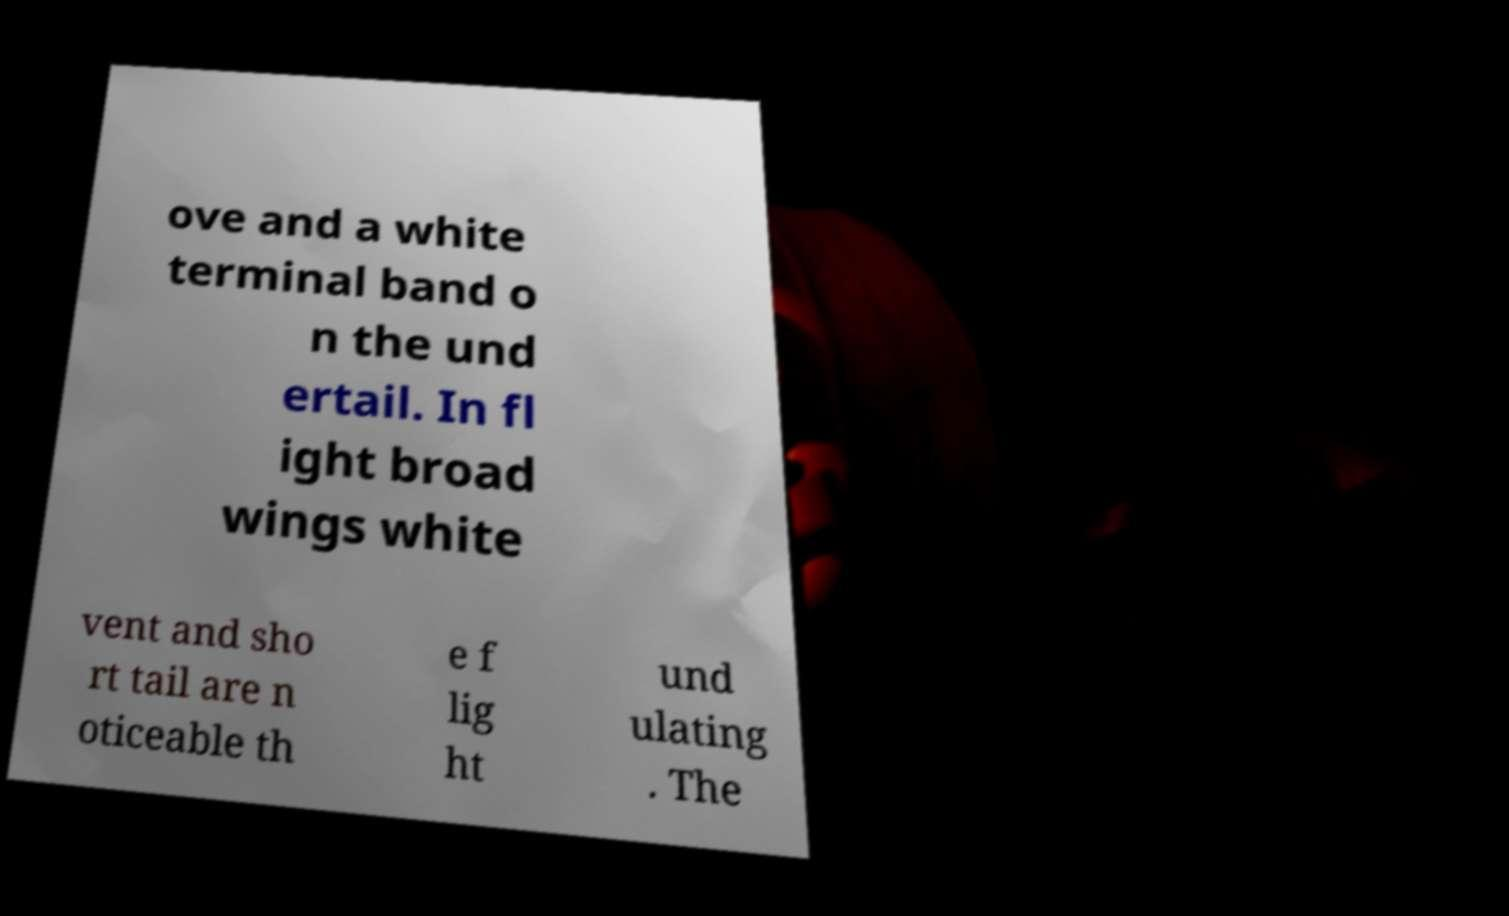For documentation purposes, I need the text within this image transcribed. Could you provide that? ove and a white terminal band o n the und ertail. In fl ight broad wings white vent and sho rt tail are n oticeable th e f lig ht und ulating . The 